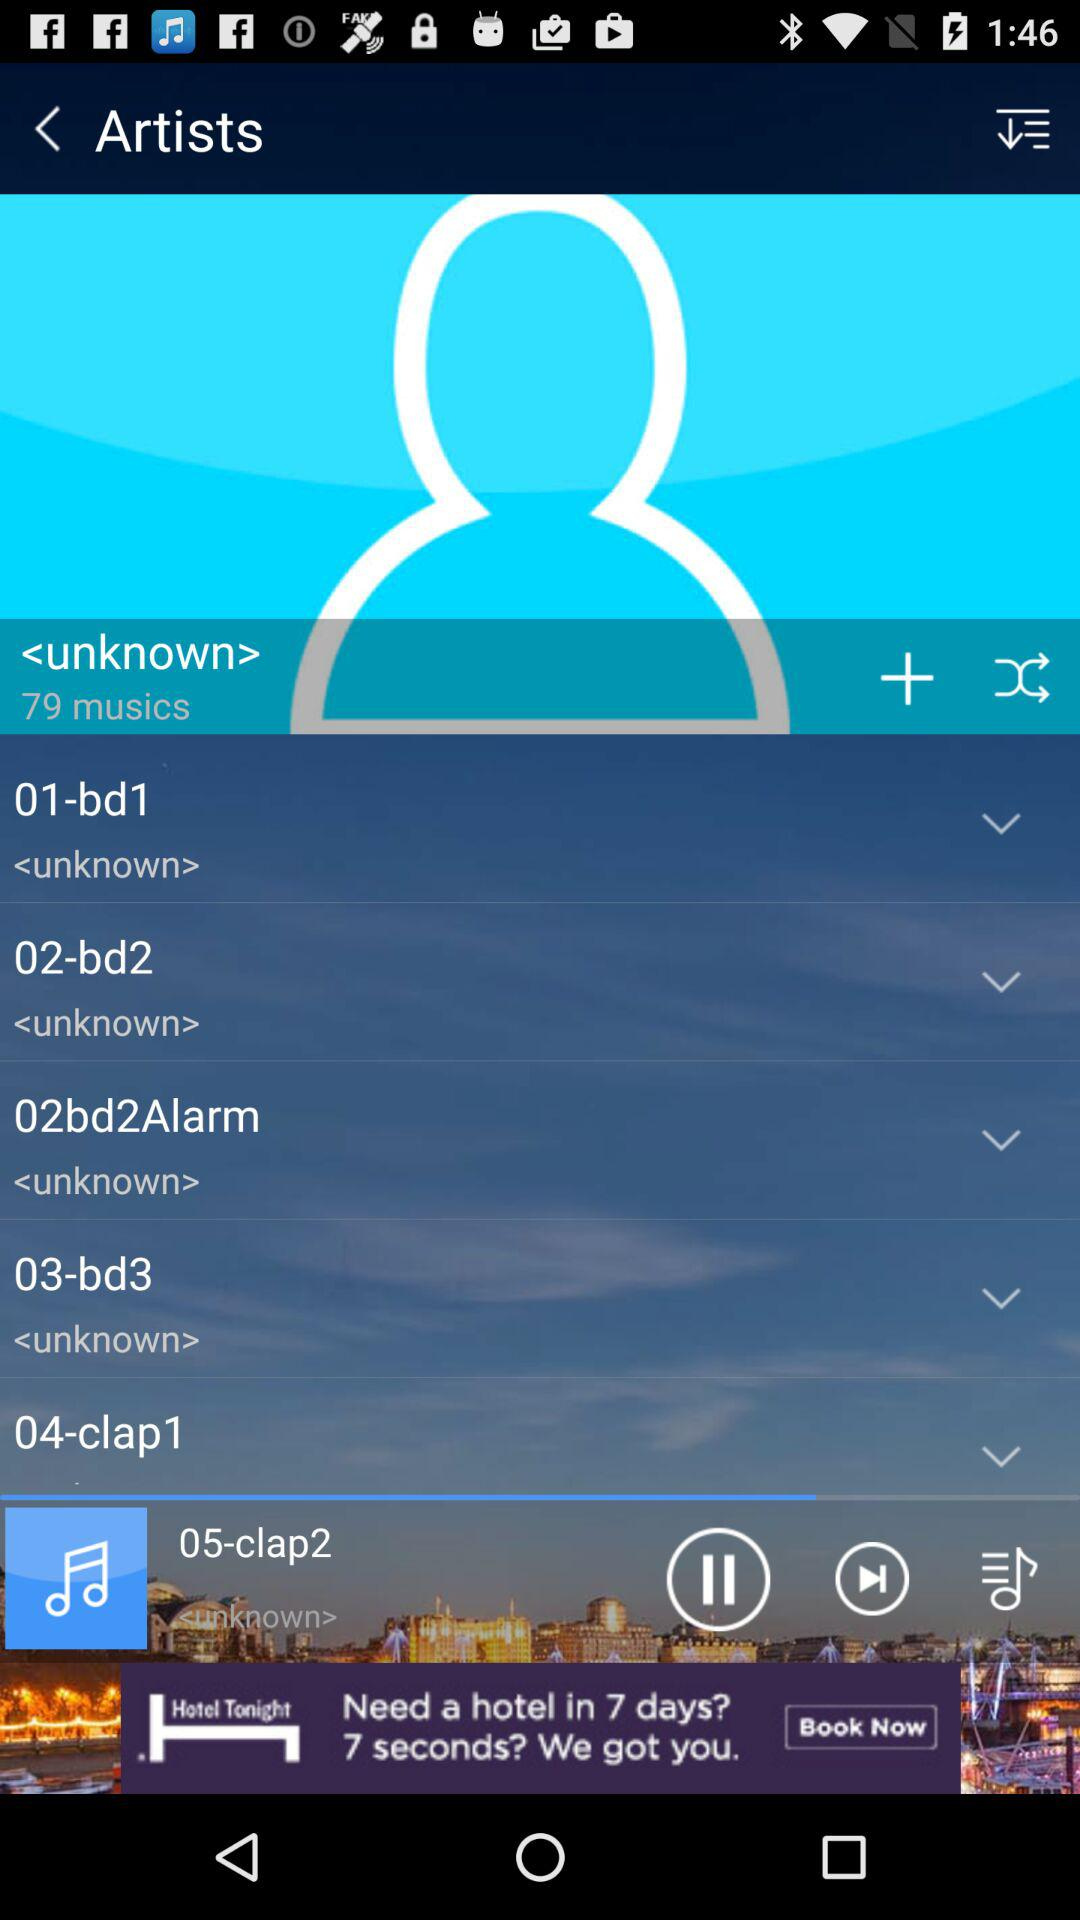Which audio is currently playing? The audio currently playing is "05-clap2". 